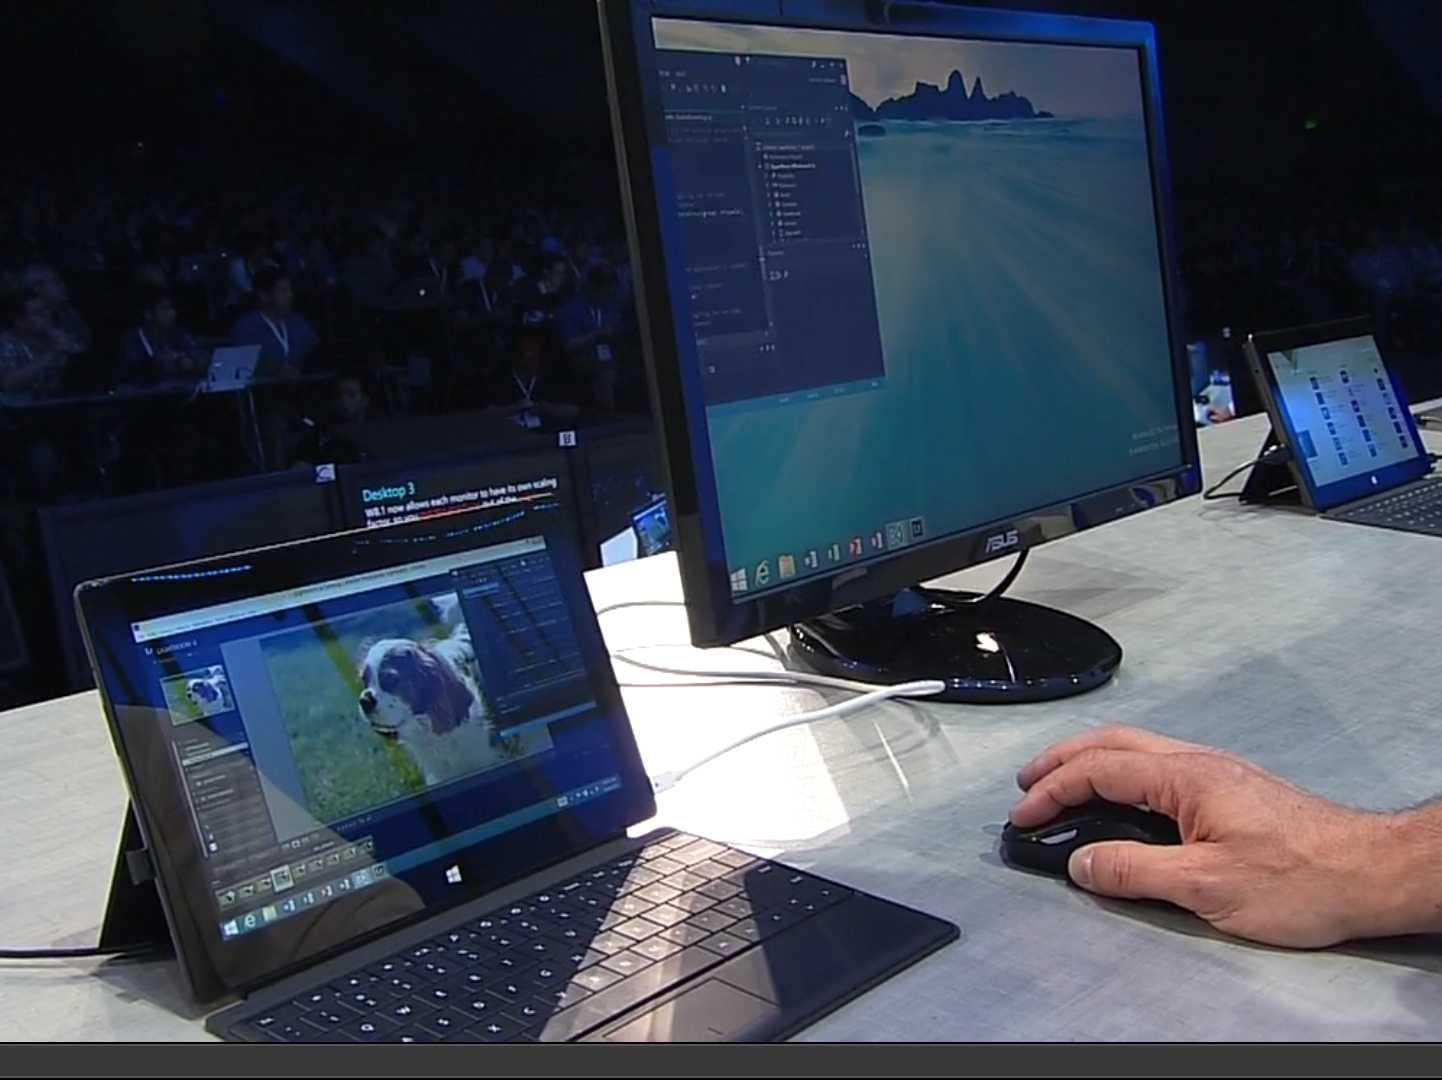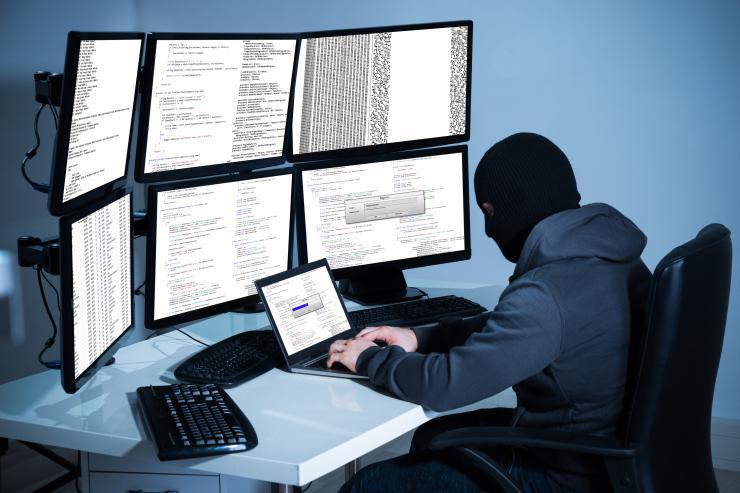The first image is the image on the left, the second image is the image on the right. Evaluate the accuracy of this statement regarding the images: "a masked man is viewing 3 monitors on a desk". Is it true? Answer yes or no. No. The first image is the image on the left, the second image is the image on the right. Considering the images on both sides, is "In the left image, there's a man in a mask and hoodie typing on a keyboard with three monitors." valid? Answer yes or no. No. 